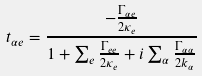<formula> <loc_0><loc_0><loc_500><loc_500>t _ { \alpha e } = \frac { - \frac { \Gamma _ { \alpha e } } { 2 \kappa _ { e } } } { 1 + \sum _ { e } \frac { \Gamma _ { e e } } { 2 \kappa _ { e } } + i \sum _ { \alpha } \frac { \Gamma _ { \alpha \alpha } } { 2 k _ { \alpha } } }</formula> 